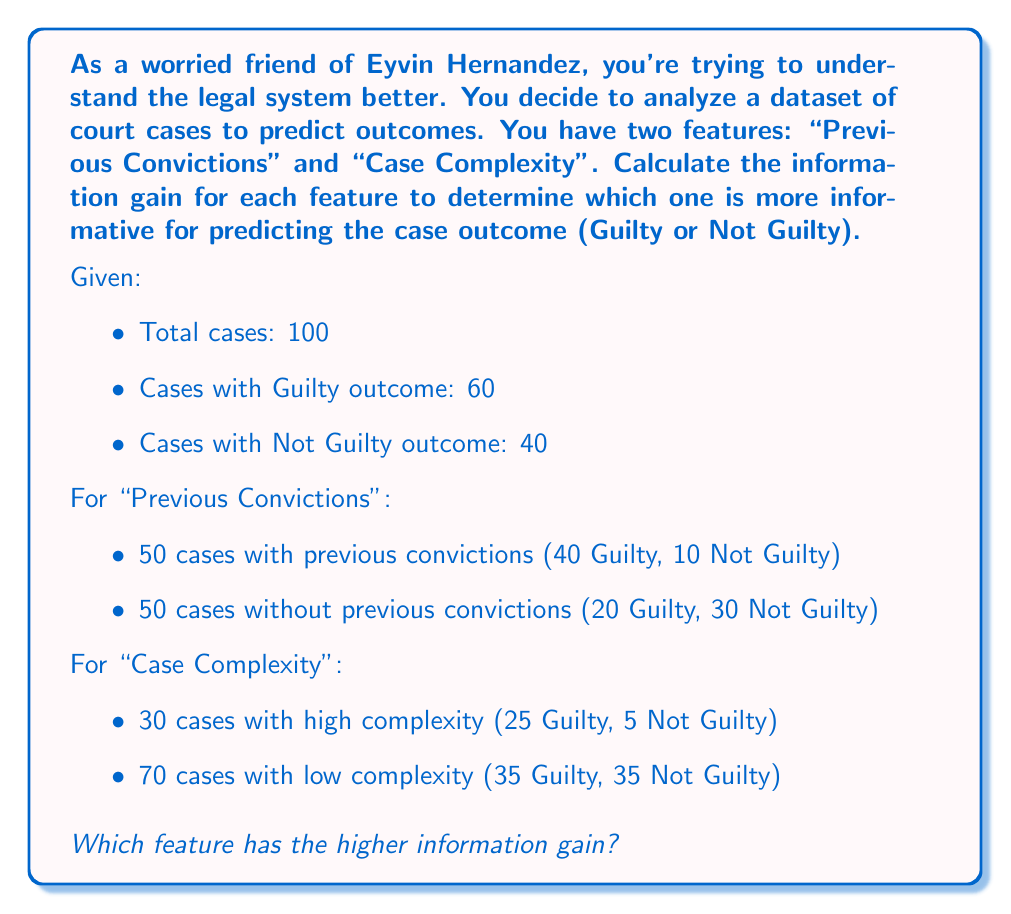Help me with this question. To solve this problem, we need to calculate the information gain for each feature. Information gain is the difference between the entropy of the target variable (case outcome) and the weighted sum of entropies after splitting on the feature.

Step 1: Calculate the entropy of the target variable (case outcome)

The entropy is given by the formula:
$$H(S) = -\sum_{i=1}^{n} p_i \log_2(p_i)$$

Where $p_i$ is the probability of each class.

$$H(S) = -(\frac{60}{100} \log_2(\frac{60}{100}) + \frac{40}{100} \log_2(\frac{40}{100})) \approx 0.9710$$

Step 2: Calculate the entropy after splitting on "Previous Convictions"

For cases with previous convictions:
$$H(S_{prev}) = -(\frac{40}{50} \log_2(\frac{40}{50}) + \frac{10}{50} \log_2(\frac{10}{50})) \approx 0.7219$$

For cases without previous convictions:
$$H(S_{no\_prev}) = -(\frac{20}{50} \log_2(\frac{20}{50}) + \frac{30}{50} \log_2(\frac{30}{50})) \approx 0.9710$$

Weighted sum:
$$H_{prev\_convictions} = \frac{50}{100} \cdot 0.7219 + \frac{50}{100} \cdot 0.9710 = 0.8465$$

Information gain for "Previous Convictions":
$$IG_{prev\_convictions} = H(S) - H_{prev\_convictions} = 0.9710 - 0.8465 = 0.1245$$

Step 3: Calculate the entropy after splitting on "Case Complexity"

For high complexity cases:
$$H(S_{high}) = -(\frac{25}{30} \log_2(\frac{25}{30}) + \frac{5}{30} \log_2(\frac{5}{30})) \approx 0.6500$$

For low complexity cases:
$$H(S_{low}) = -(\frac{35}{70} \log_2(\frac{35}{70}) + \frac{35}{70} \log_2(\frac{35}{70})) = 1.0000$$

Weighted sum:
$$H_{complexity} = \frac{30}{100} \cdot 0.6500 + \frac{70}{100} \cdot 1.0000 = 0.8950$$

Information gain for "Case Complexity":
$$IG_{complexity} = H(S) - H_{complexity} = 0.9710 - 0.8950 = 0.0760$$

Step 4: Compare the information gains

Information gain for "Previous Convictions": 0.1245
Information gain for "Case Complexity": 0.0760
Answer: The feature with the higher information gain is "Previous Convictions" with an information gain of 0.1245, compared to "Case Complexity" with an information gain of 0.0760. 